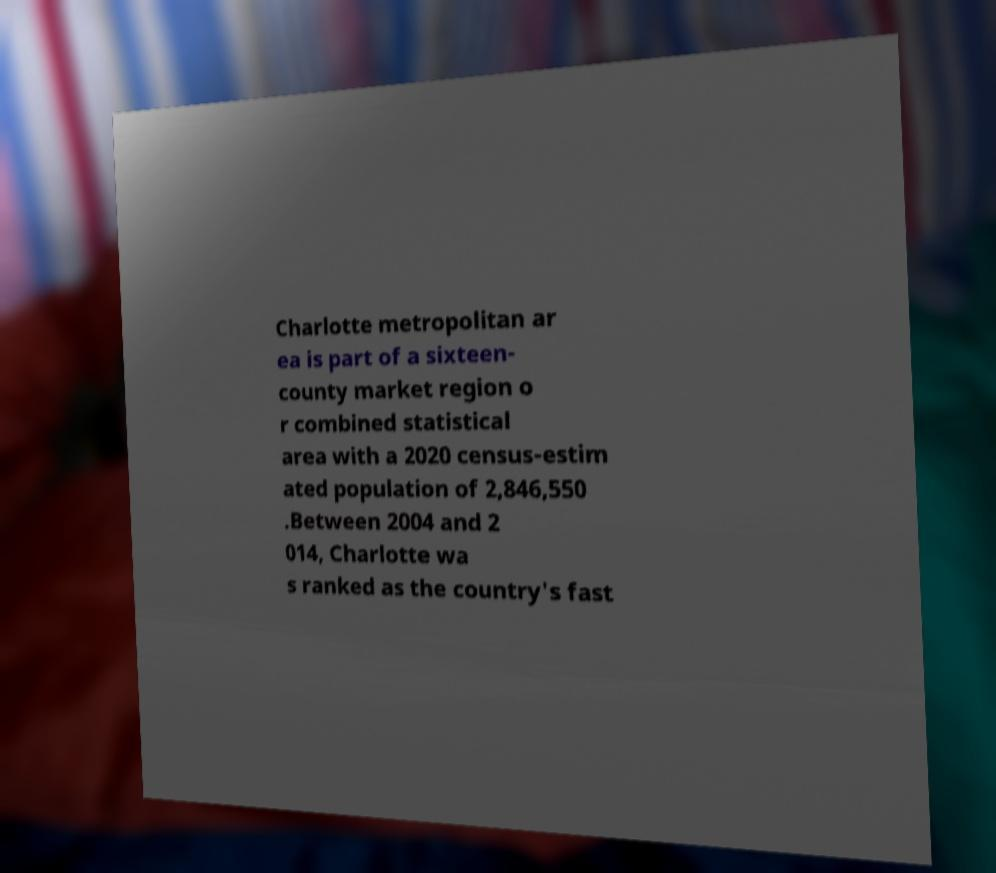Please identify and transcribe the text found in this image. Charlotte metropolitan ar ea is part of a sixteen- county market region o r combined statistical area with a 2020 census-estim ated population of 2,846,550 .Between 2004 and 2 014, Charlotte wa s ranked as the country's fast 